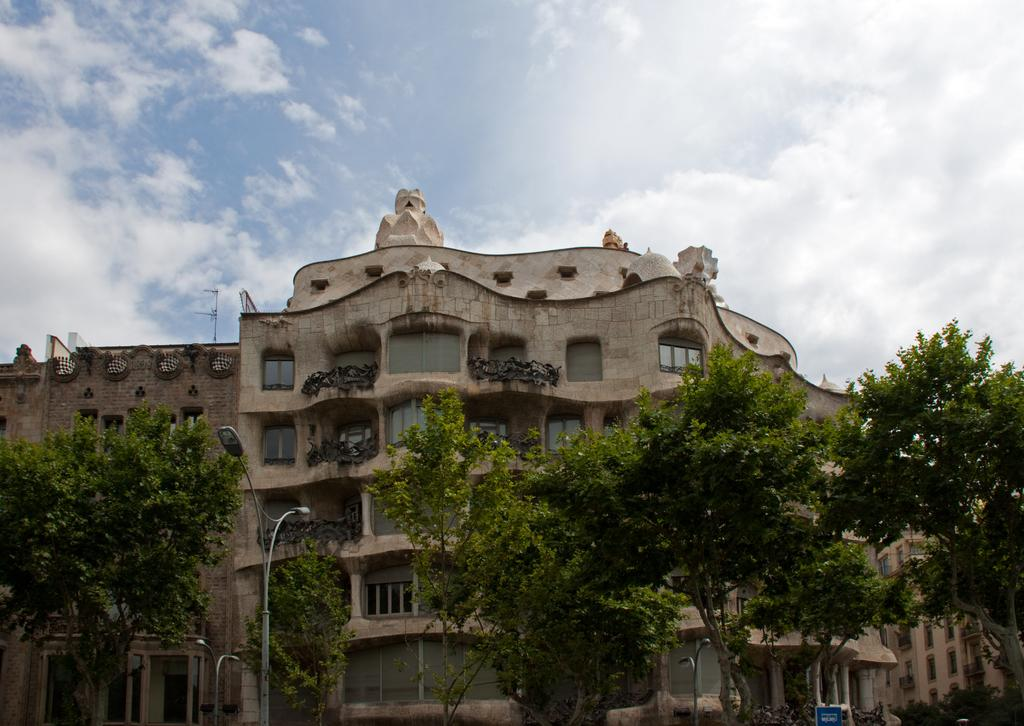What type of structure is visible in the image? There is a building in the image. What is located in front of the building? There are many trees, street lights, and boards in front of the building. How are the trees arranged in front of the building? The trees are planted in front of the building. What is visible at the top of the image? The sky is visible at the top of the image. What can be observed in the sky? Clouds are present in the sky. How many legs does the building have in the image? Buildings do not have legs; they are stationary structures. 